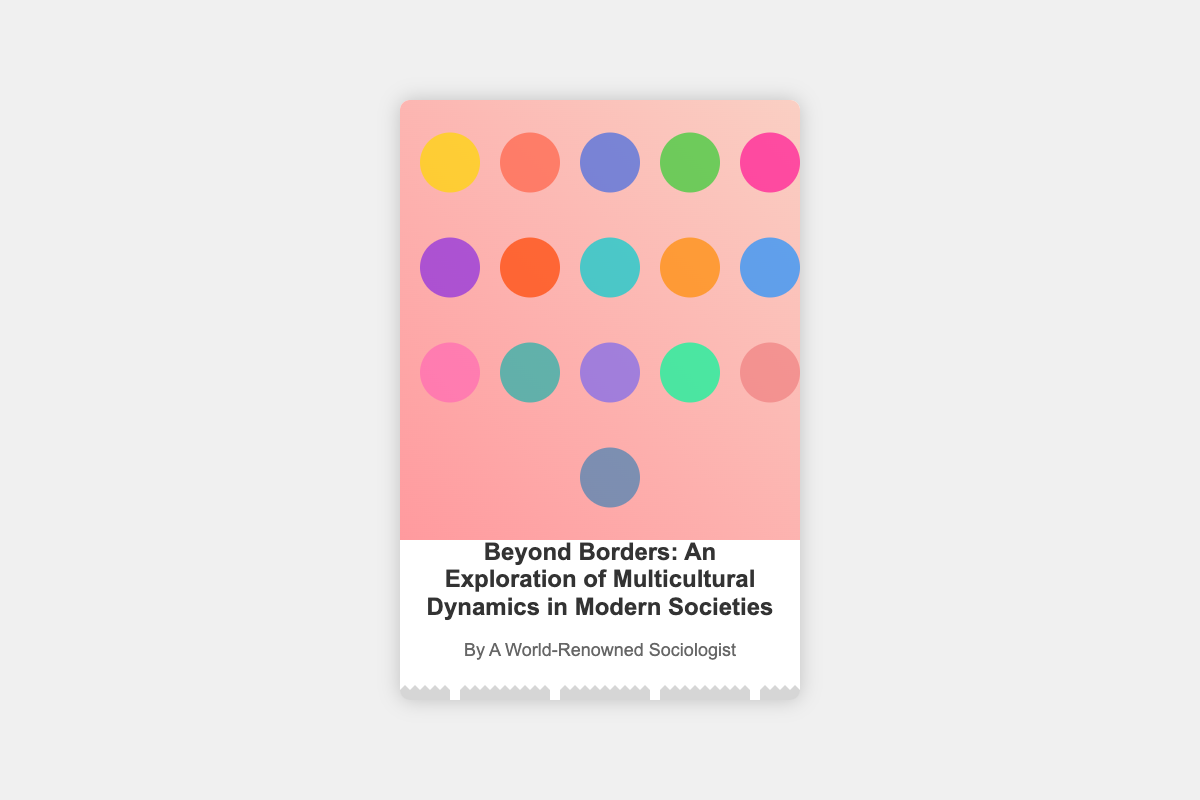What is the title of the book? The title is prominently displayed in the cover design, showcasing the main subject of the analysis.
Answer: Beyond Borders: An Exploration of Multicultural Dynamics in Modern Societies Who is the author mentioned on the cover? The author is identified below the title, indicating the expertise of the person behind the research.
Answer: A World-Renowned Sociologist What visual element is used to represent different ethnic groups? The design includes a specific imagery that symbolizes the diversity present in modern urban settings.
Answer: Mosaic of faces What is the dominant color scheme of the cover? The background and faces in the mosaic provide clues about the overall color palette used in the design.
Answer: Multicolored What is the primary theme of the book? The theme is conveyed through the title, focusing on the interactions of diverse communities.
Answer: Multicultural dynamics How many faces are depicted in the mosaic? The design shows various colored circles which represent faces, indicating a specific count.
Answer: Sixteen What visual element at the bottom adds a urban aesthetic? The design includes an additional characteristic that enhances the theme of modern urban settings.
Answer: Urban background What aspect of society does the book primarily explore? The focus is outlined in the title, highlighting a specific area of societal relations.
Answer: Integration within urban settings What type of imagery is present on the book cover? The cover includes certain artistic designs that reflect the subject matter in an engaging way.
Answer: Stylized portraits and mosaics 